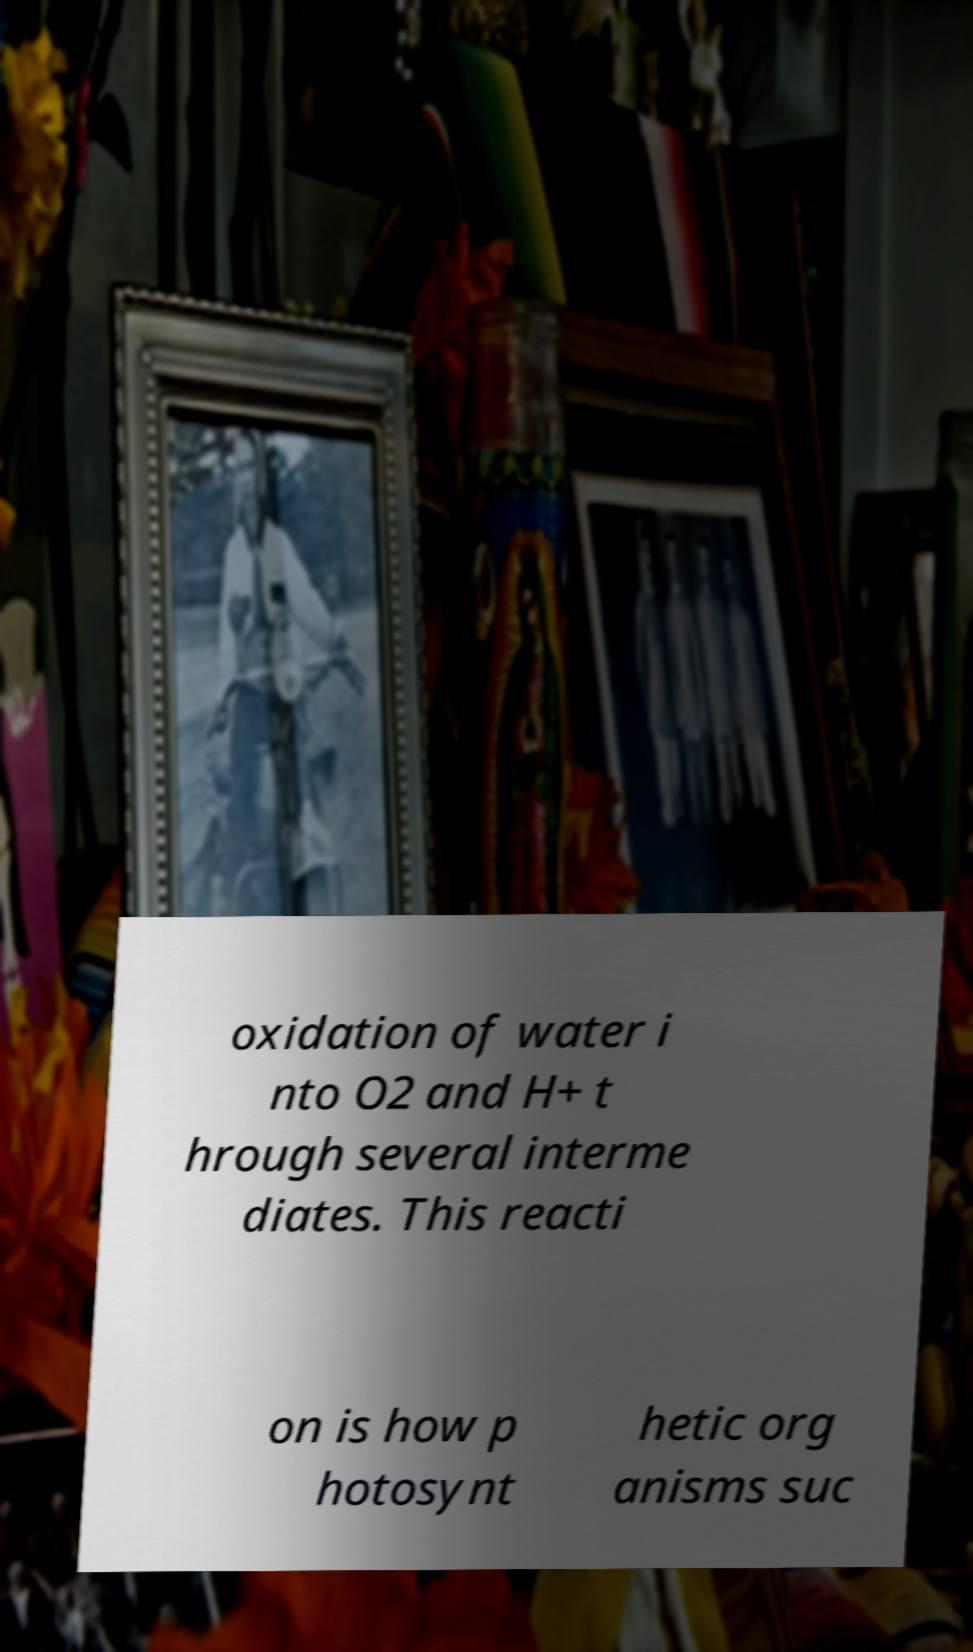What messages or text are displayed in this image? I need them in a readable, typed format. oxidation of water i nto O2 and H+ t hrough several interme diates. This reacti on is how p hotosynt hetic org anisms suc 